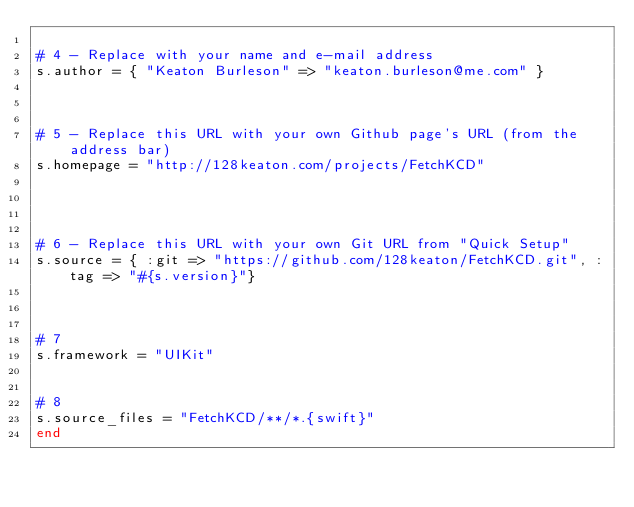<code> <loc_0><loc_0><loc_500><loc_500><_Ruby_>
# 4 - Replace with your name and e-mail address
s.author = { "Keaton Burleson" => "keaton.burleson@me.com" }



# 5 - Replace this URL with your own Github page's URL (from the address bar)
s.homepage = "http://128keaton.com/projects/FetchKCD"




# 6 - Replace this URL with your own Git URL from "Quick Setup"
s.source = { :git => "https://github.com/128keaton/FetchKCD.git", :tag => "#{s.version}"}



# 7
s.framework = "UIKit"


# 8
s.source_files = "FetchKCD/**/*.{swift}"
end
</code> 